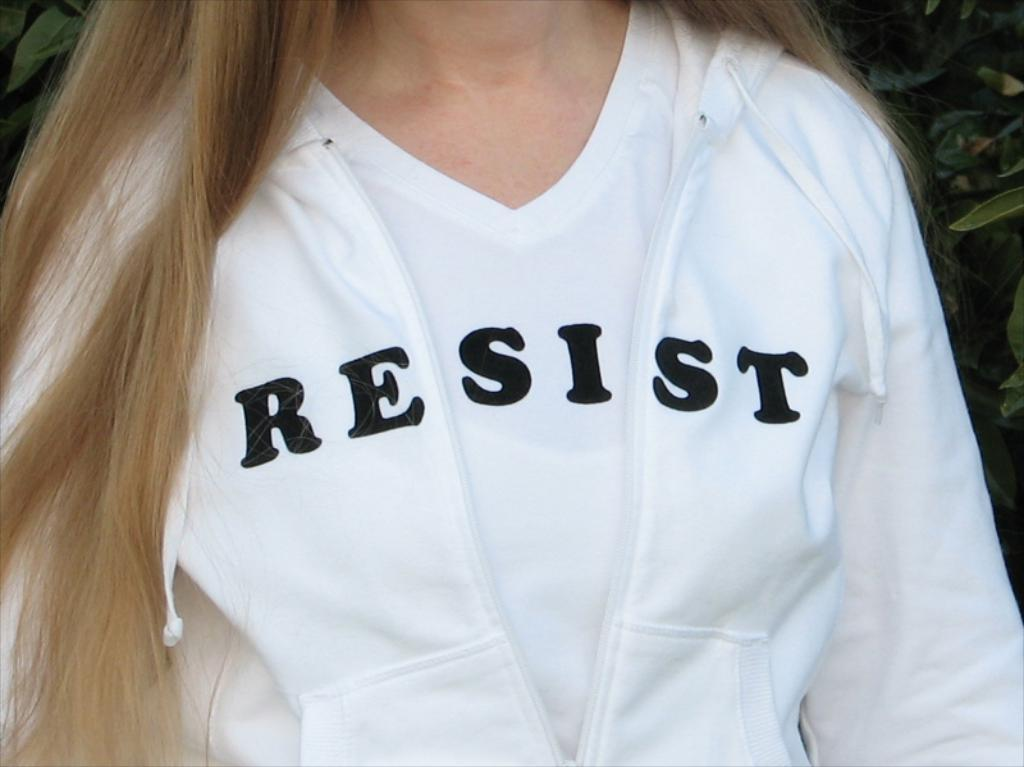<image>
Render a clear and concise summary of the photo. A woman's sweatshirt and shirt form the word "resist". 